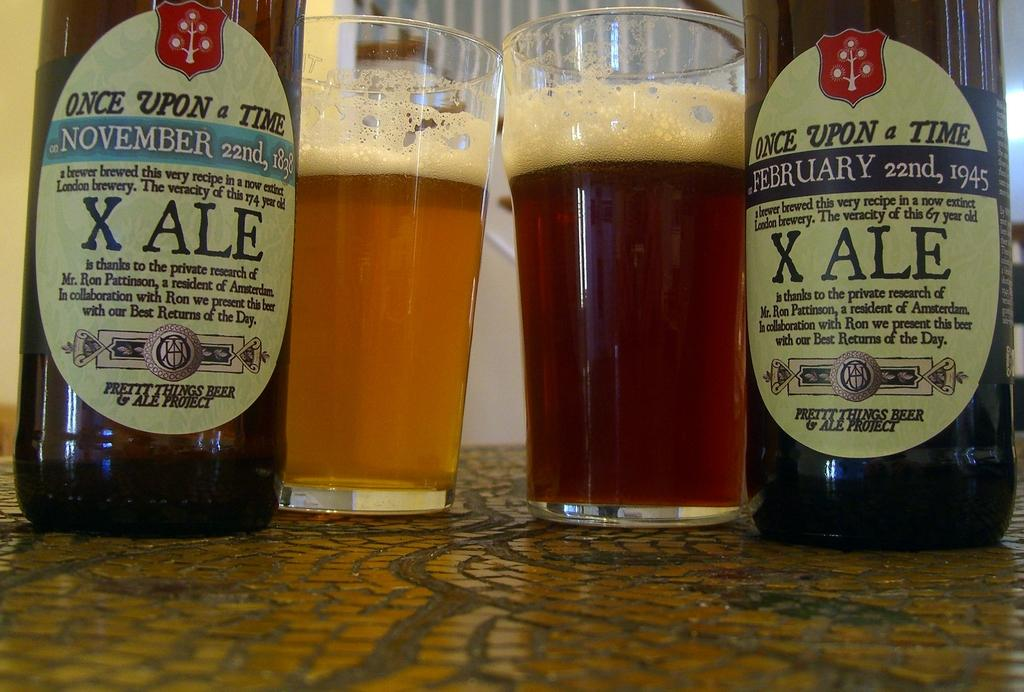<image>
Render a clear and concise summary of the photo. Two bottle of ale from the London Brewery and 2 glasses are on a table. 